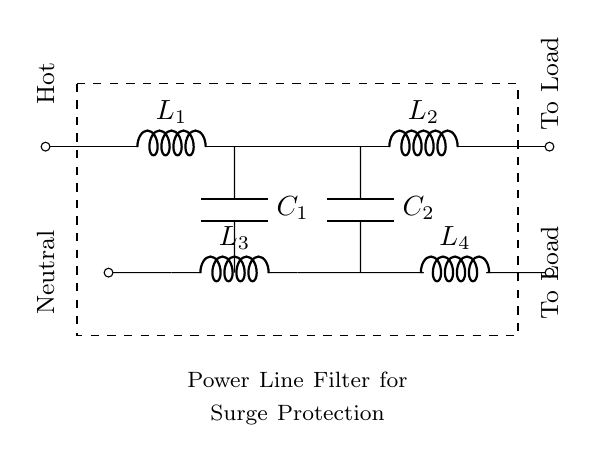What components are present in the circuit? The circuit includes inductors L1, L2, L3, L4 and capacitors C1, C2.
Answer: Inductors and capacitors What is the orientation of the connection to the hot and neutral lines? The hot line is shown at the top of the circuit, while the neutral line is at the bottom. Each is labeled accordingly.
Answer: Top and bottom How many inductors are there in this circuit? By counting the labeled inductors in the diagram, we can see that there are four inductors total: L1, L2, L3, and L4.
Answer: Four What is the purpose of this circuit? The purpose is indicated in the annotation at the bottom, stating it is a power line filter for surge protection, which suggests it is designed to mitigate voltage spikes.
Answer: Surge protection Why are there capacitors present in the circuit? Capacitors are typically used in powerline filters to smooth out fluctuations in voltage and provide a path for high-frequency signals to ground, thereby enhancing surge protection.
Answer: To smooth voltage fluctuations What is the effect of having both inductors and capacitors in the circuit? The combination of inductors and capacitors creates a filter that can block or attenuate certain frequencies while allowing others to pass, enhancing the surge protection capabilities of the circuit.
Answer: Form a filter What is indicated by the dashed rectangle surrounding the components? The dashed rectangle encloses the main components of the circuit, which shows the focus area for the filter circuit and its schematic representation for clarity.
Answer: Circuit enclosure 